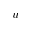Convert formula to latex. <formula><loc_0><loc_0><loc_500><loc_500>u</formula> 